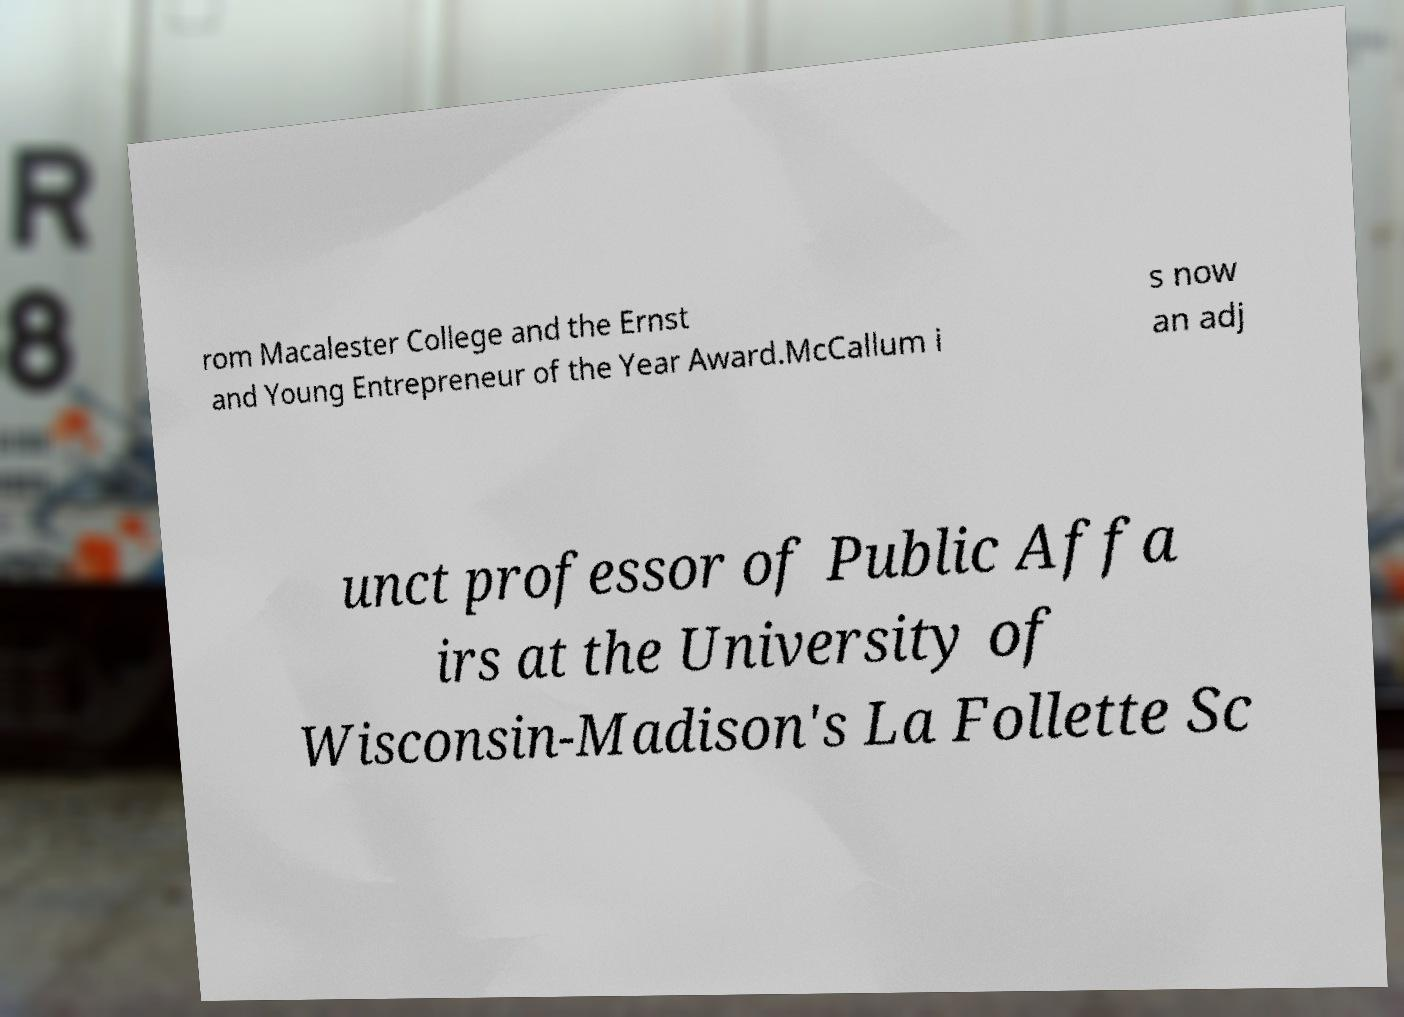I need the written content from this picture converted into text. Can you do that? rom Macalester College and the Ernst and Young Entrepreneur of the Year Award.McCallum i s now an adj unct professor of Public Affa irs at the University of Wisconsin-Madison's La Follette Sc 